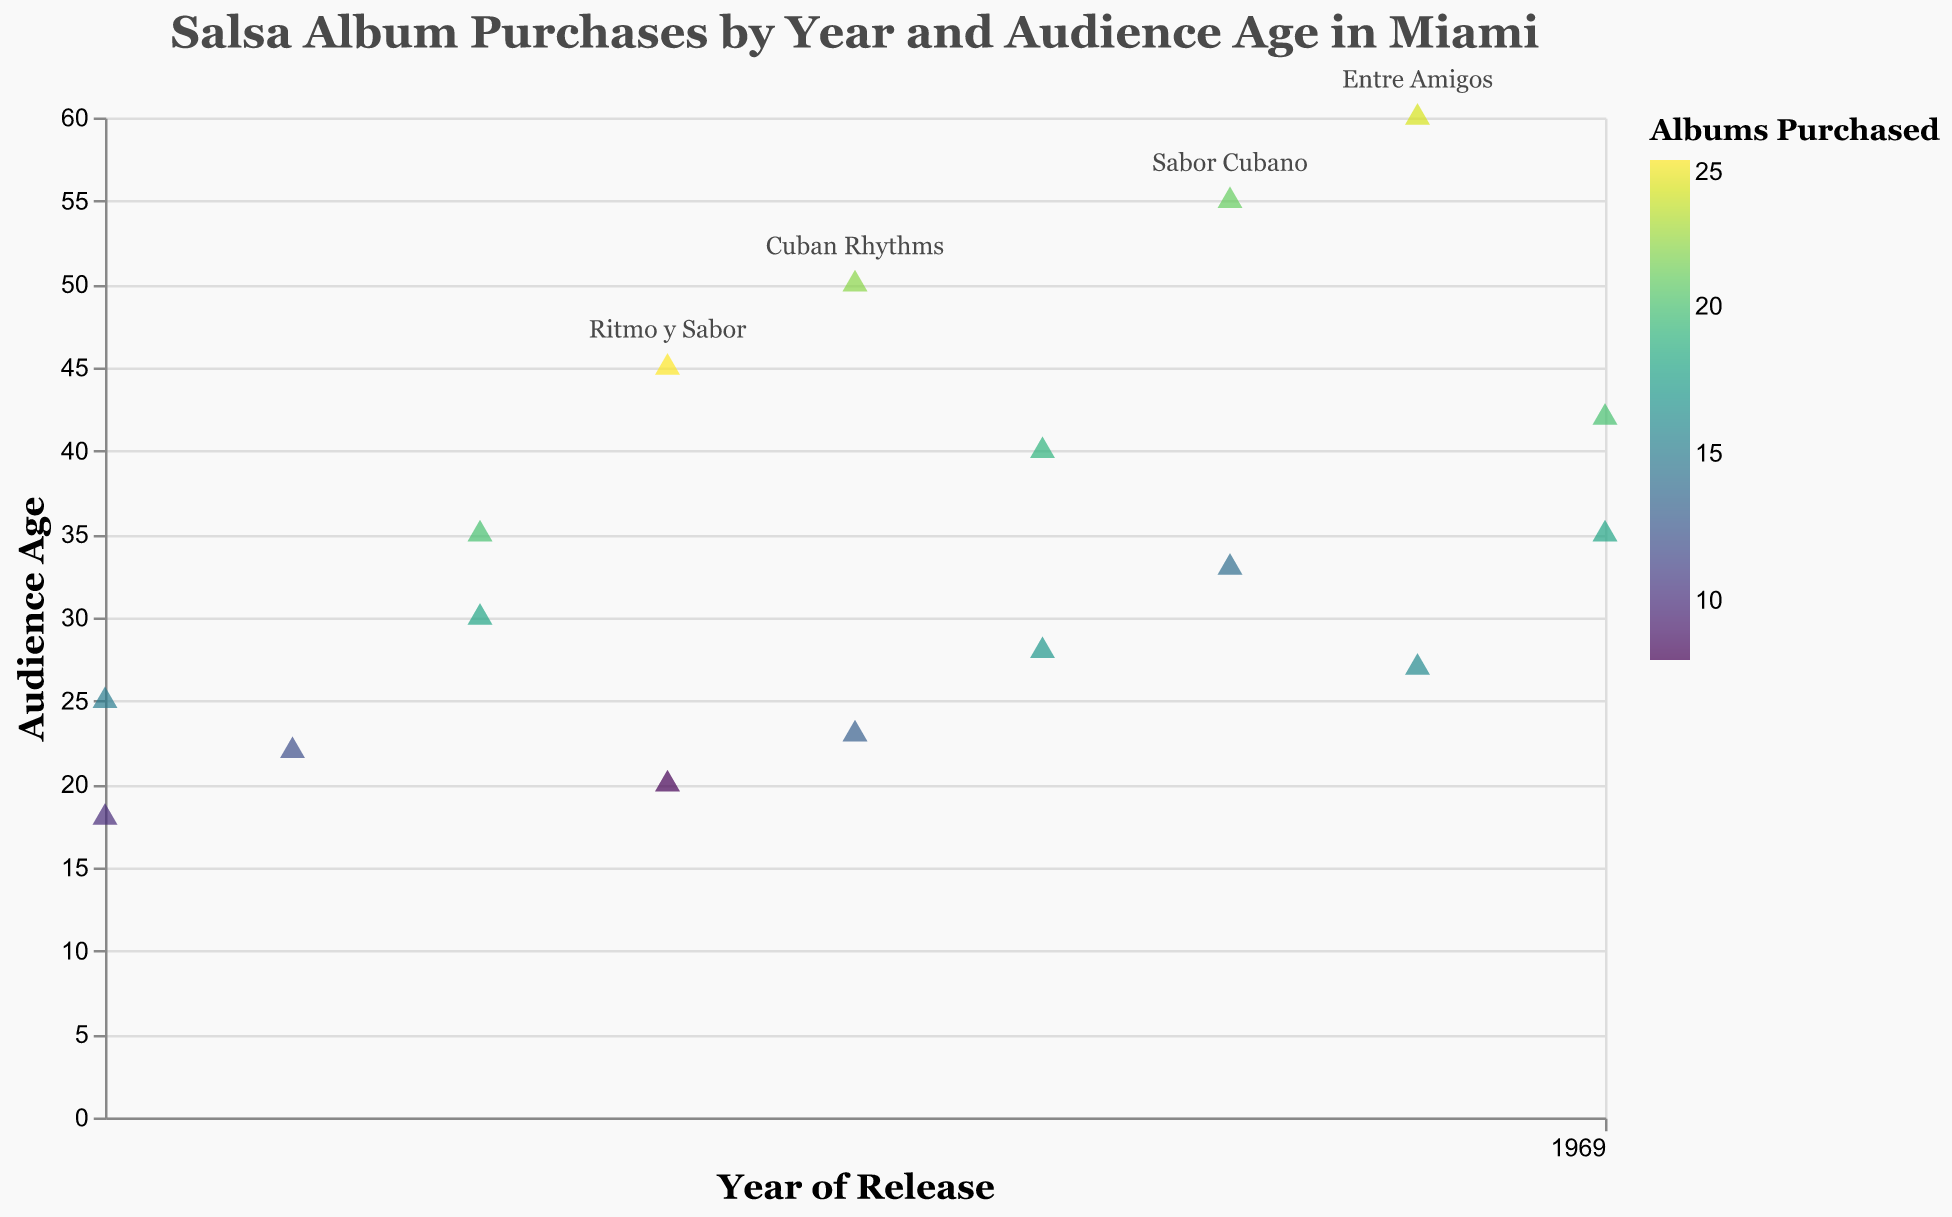How many albums were released in 2015? Looking at the X-axis labeled "Year of Release", locate the year 2015 and count the number of points representing albums released in that year.
Answer: 2 Which album had the highest number of purchases in 2018? Locate the points for the year 2018 on the X-axis, then compare the values represented by different colors (indicating the number of albums purchased). Find the album with the darkest color or highest value in the tooltip.
Answer: "Ritmo y Sabor" What is the total number of albums purchased by audiences aged 40 and above over all years? Filter out the points on the Y-axis for audience ages 40 and above (40, 45, 50, 55, and 60), and sum up the associated "Number_of_Albums_Purchased" values for these points.
Answer: 131 Did the album "Noches de Salsa" sell more or less than "Havana Nights"? Identify the points corresponding to "Noches de Salsa" and "Havana Nights" by checking the tooltips. Compare their "Number_of_Albums_Purchased" values.
Answer: More Which audience age group purchased the most albums over the period? Identify the points on the Y-axis with the highest "Number_of_Albums_Purchased" values regardless of the year. Sum up the purchases for each age group and find the maximum.
Answer: 45 What trend do you observe for the audience age group of 35 years over the years in terms of purchases? Locate the points for the audience age of 35 on the Y-axis and observe their horizontal placement (years) on the X-axis. Take note of changes in the color intensity (number of purchases) over time.
Answer: Increasing trend Which year saw the highest number of purchases for any single album? Examine the horizontal axis for all years, checking the tooltips and identifying the point or points with the highest "Number_of_Albums_Purchased" value.
Answer: 2018 Is there a correlation between audience age and the number of albums purchased? Observe the scatter plot to see if there is any pattern (increase or decrease) in the "Number_of_Albums_Purchased" as the audience age changes on the Y-axis.
Answer: Yes, older audiences tend to purchase more albums 